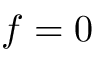<formula> <loc_0><loc_0><loc_500><loc_500>f = 0</formula> 